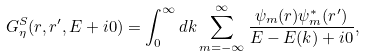<formula> <loc_0><loc_0><loc_500><loc_500>G _ { \eta } ^ { S } ( r , r ^ { \prime } , E + i 0 ) = \int _ { 0 } ^ { \infty } d k \sum _ { m = - \infty } ^ { \infty } \frac { \psi _ { m } ( r ) \psi _ { m } ^ { \ast } ( r ^ { \prime } ) } { E - E ( k ) + i 0 } ,</formula> 